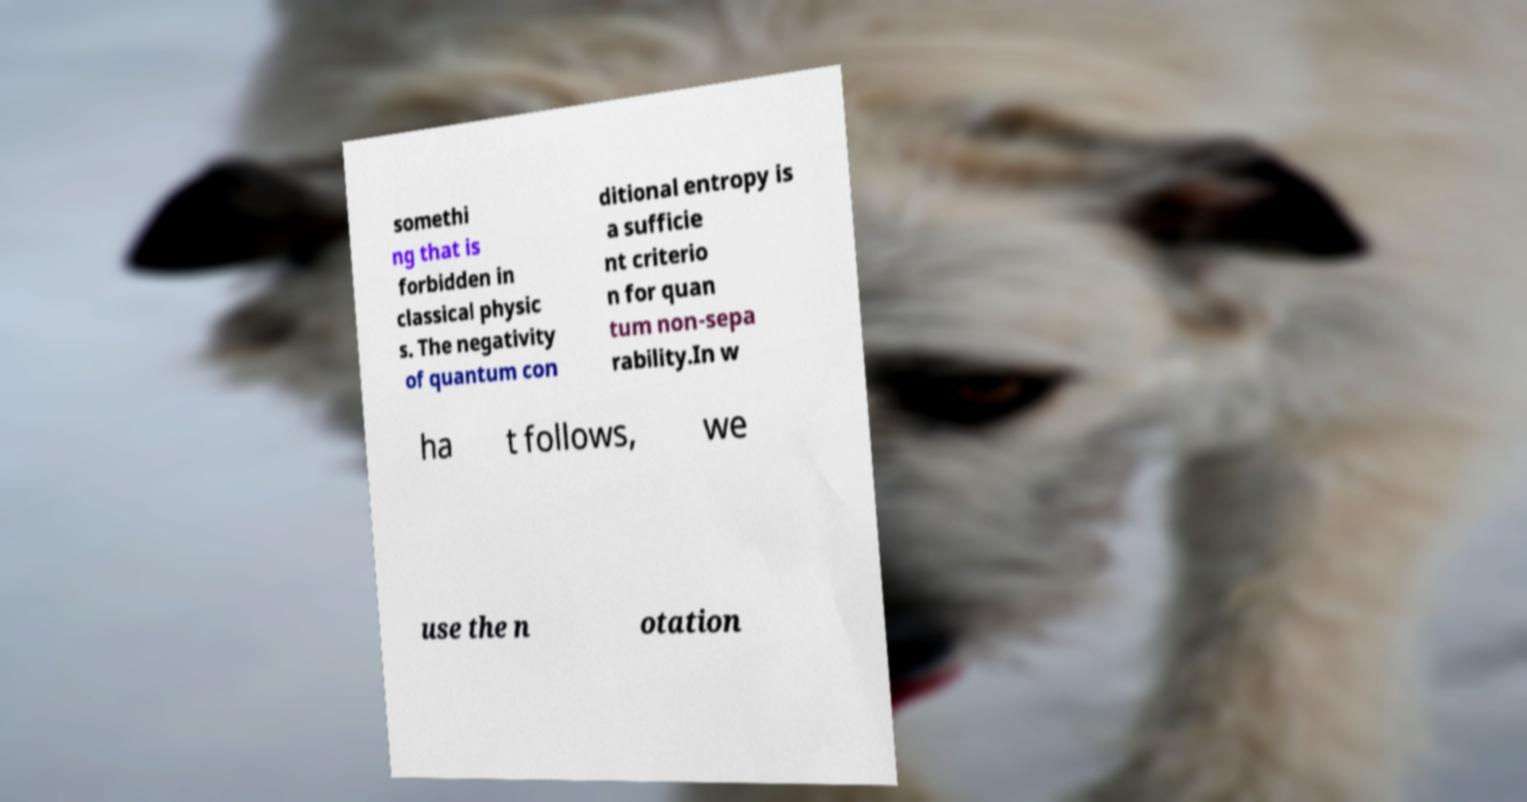Please identify and transcribe the text found in this image. somethi ng that is forbidden in classical physic s. The negativity of quantum con ditional entropy is a sufficie nt criterio n for quan tum non-sepa rability.In w ha t follows, we use the n otation 